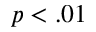Convert formula to latex. <formula><loc_0><loc_0><loc_500><loc_500>p < . 0 1</formula> 